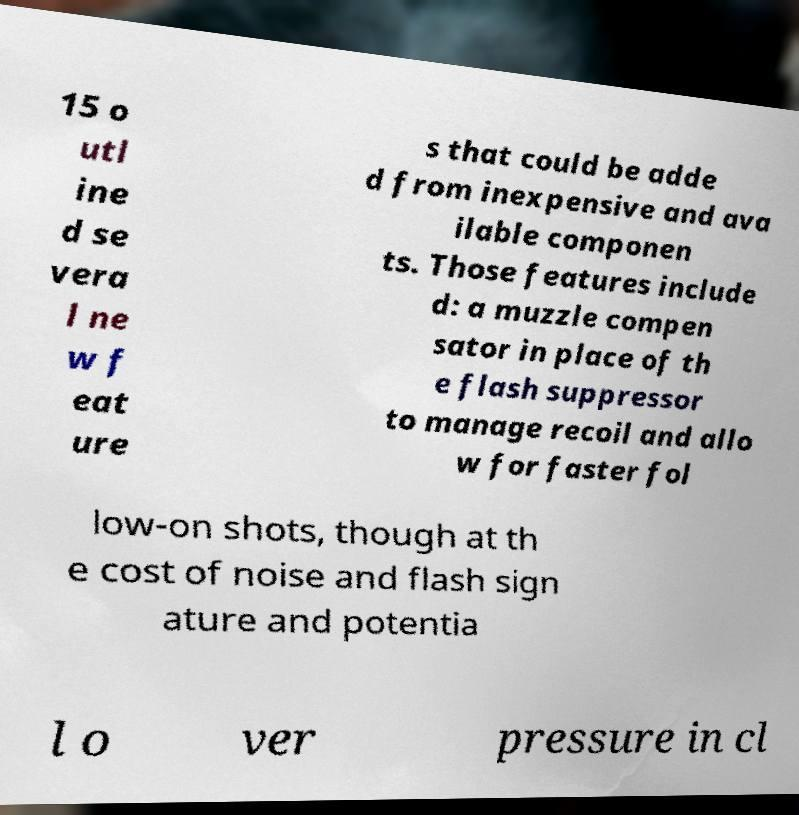There's text embedded in this image that I need extracted. Can you transcribe it verbatim? 15 o utl ine d se vera l ne w f eat ure s that could be adde d from inexpensive and ava ilable componen ts. Those features include d: a muzzle compen sator in place of th e flash suppressor to manage recoil and allo w for faster fol low-on shots, though at th e cost of noise and flash sign ature and potentia l o ver pressure in cl 